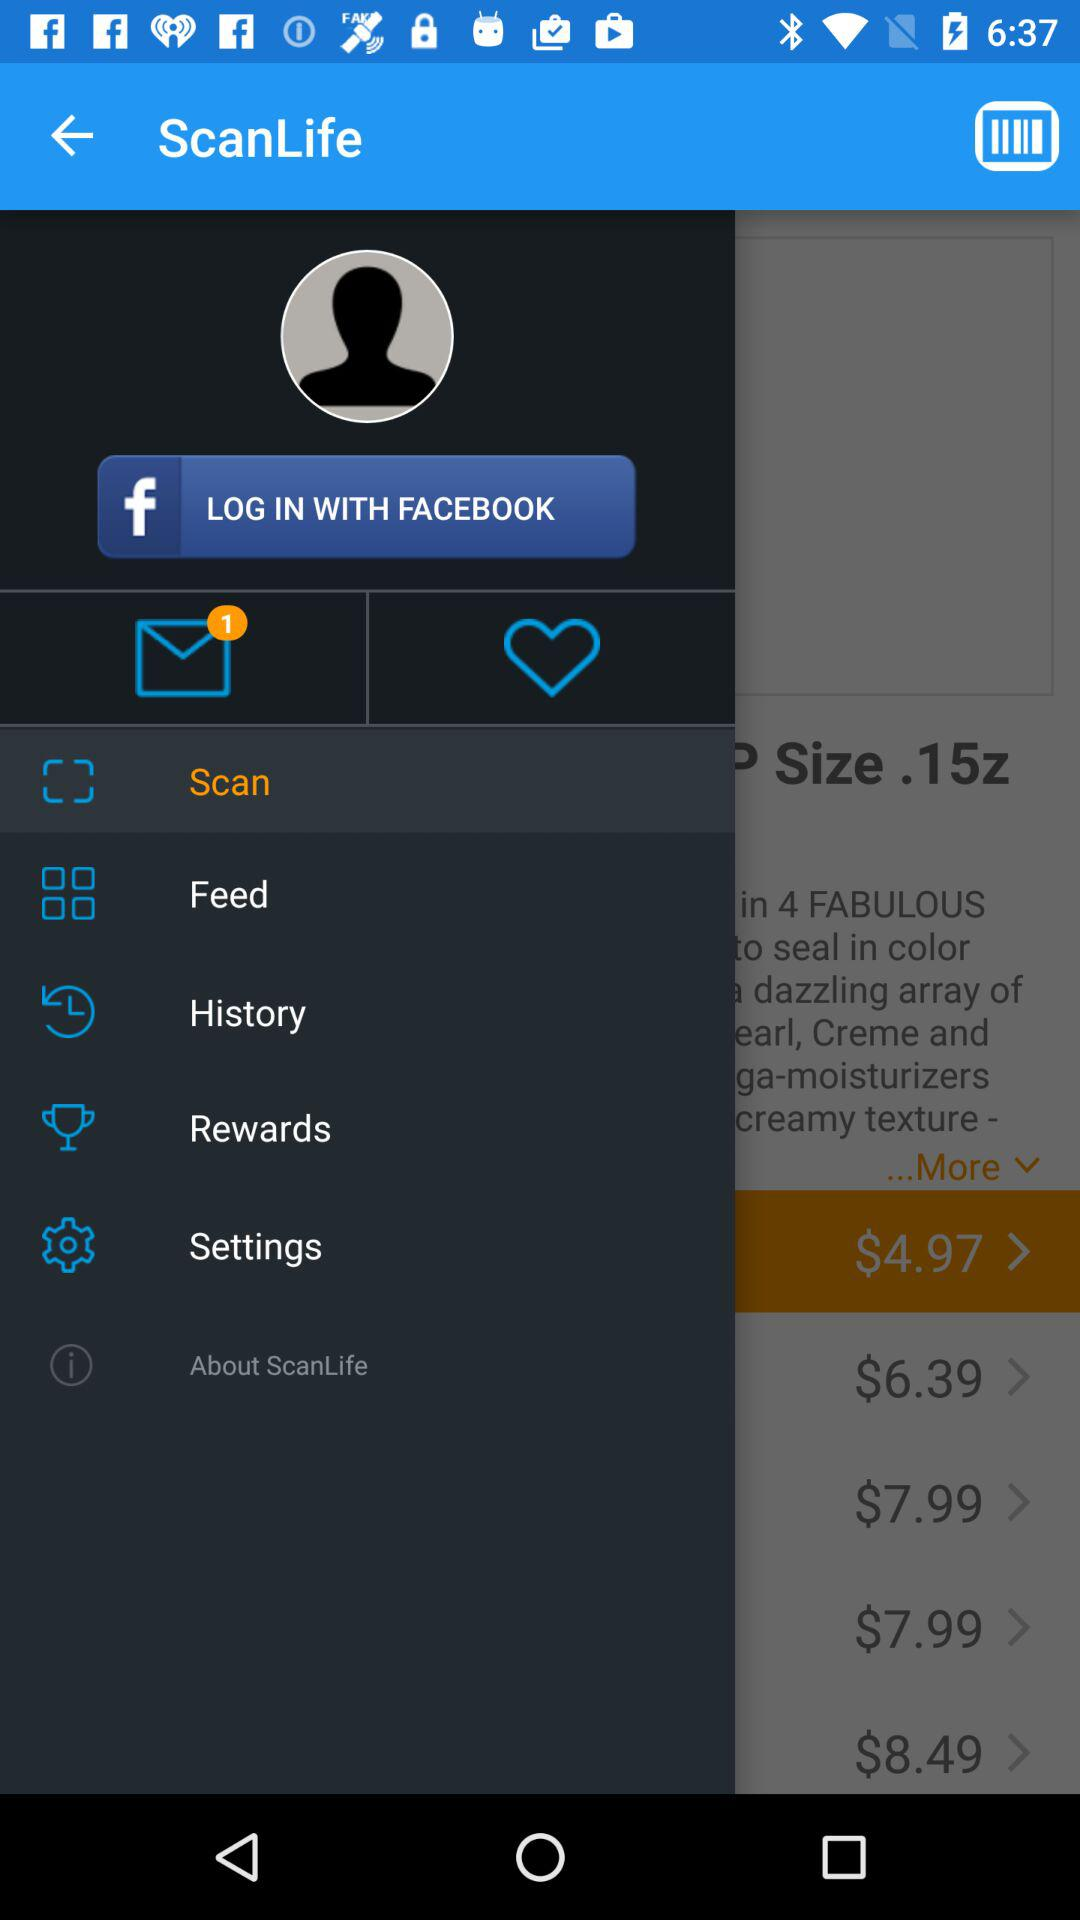What account can I use to log in? The account that you can use to log in is "FACEBOOK". 